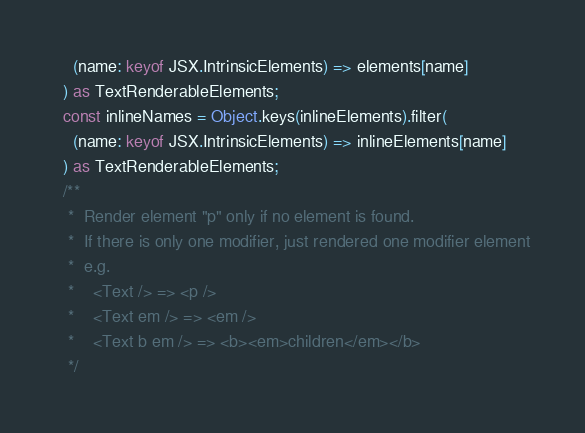Convert code to text. <code><loc_0><loc_0><loc_500><loc_500><_TypeScript_>    (name: keyof JSX.IntrinsicElements) => elements[name]
  ) as TextRenderableElements;
  const inlineNames = Object.keys(inlineElements).filter(
    (name: keyof JSX.IntrinsicElements) => inlineElements[name]
  ) as TextRenderableElements;
  /**
   *  Render element "p" only if no element is found.
   *  If there is only one modifier, just rendered one modifier element
   *  e.g.
   *    <Text /> => <p />
   *    <Text em /> => <em />
   *    <Text b em /> => <b><em>children</em></b>
   */
</code> 